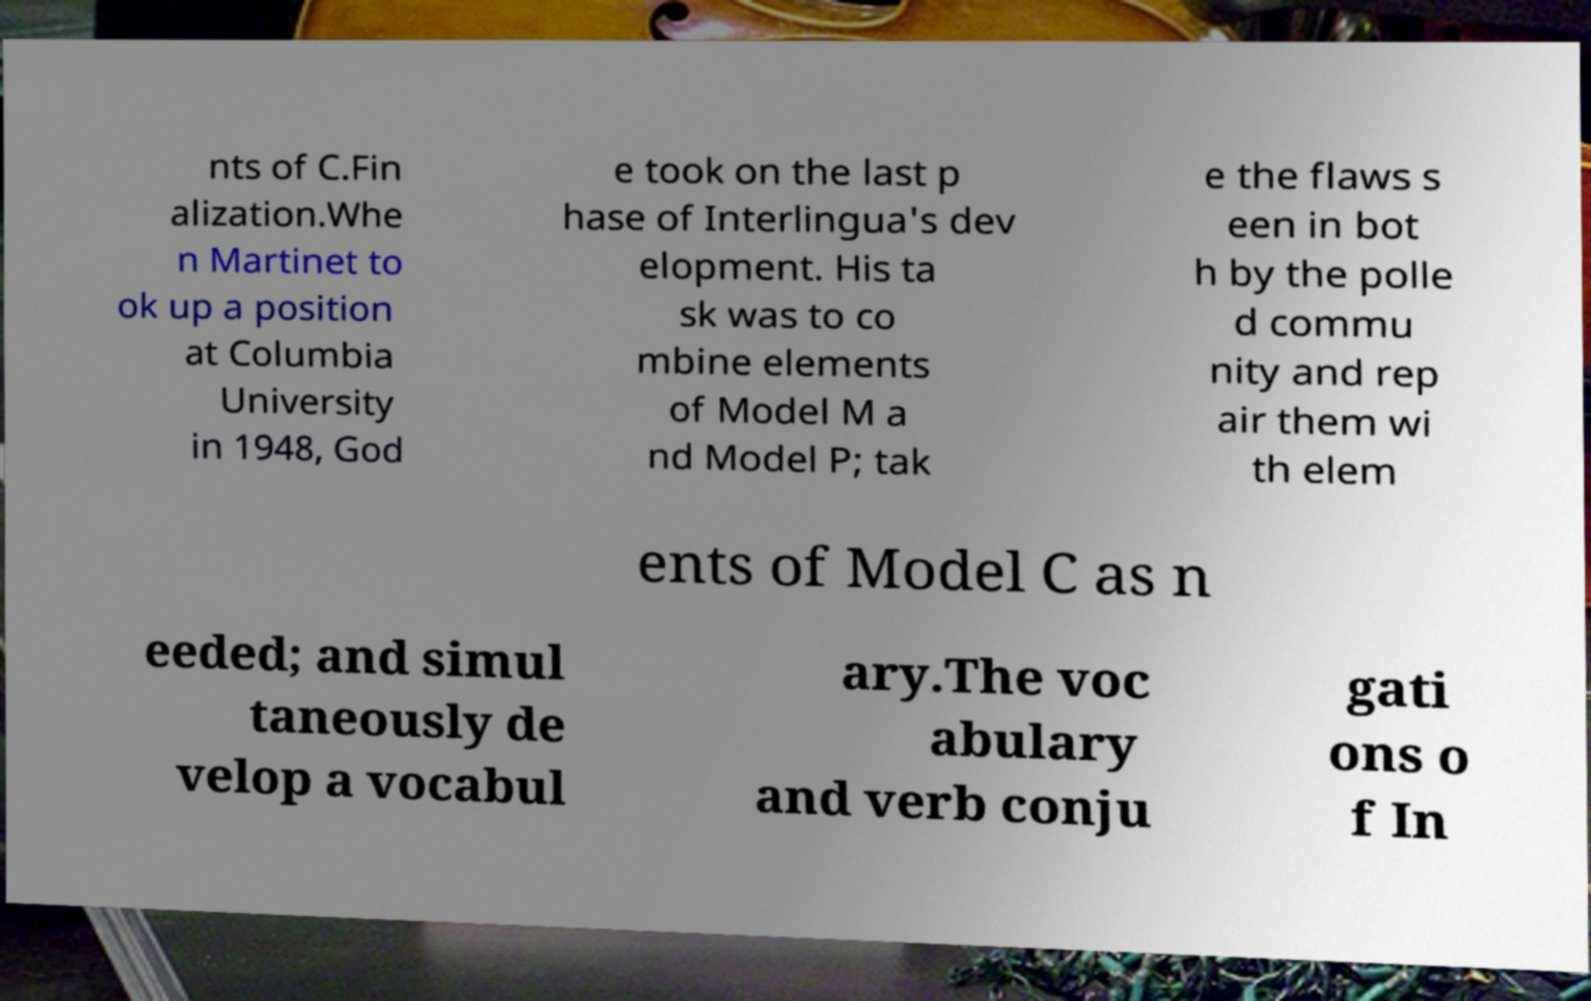Could you assist in decoding the text presented in this image and type it out clearly? nts of C.Fin alization.Whe n Martinet to ok up a position at Columbia University in 1948, God e took on the last p hase of Interlingua's dev elopment. His ta sk was to co mbine elements of Model M a nd Model P; tak e the flaws s een in bot h by the polle d commu nity and rep air them wi th elem ents of Model C as n eeded; and simul taneously de velop a vocabul ary.The voc abulary and verb conju gati ons o f In 